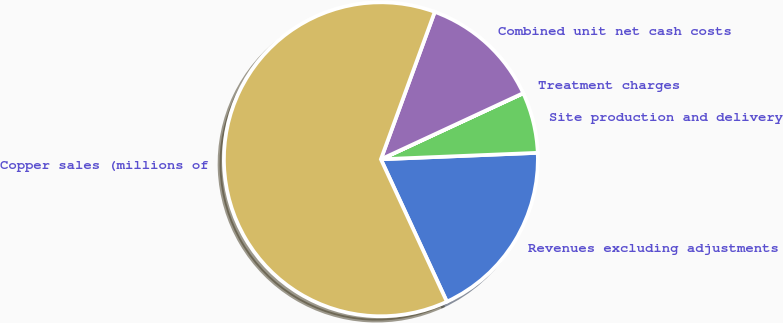Convert chart to OTSL. <chart><loc_0><loc_0><loc_500><loc_500><pie_chart><fcel>Revenues excluding adjustments<fcel>Site production and delivery<fcel>Treatment charges<fcel>Combined unit net cash costs<fcel>Copper sales (millions of<nl><fcel>18.75%<fcel>6.26%<fcel>0.01%<fcel>12.5%<fcel>62.48%<nl></chart> 